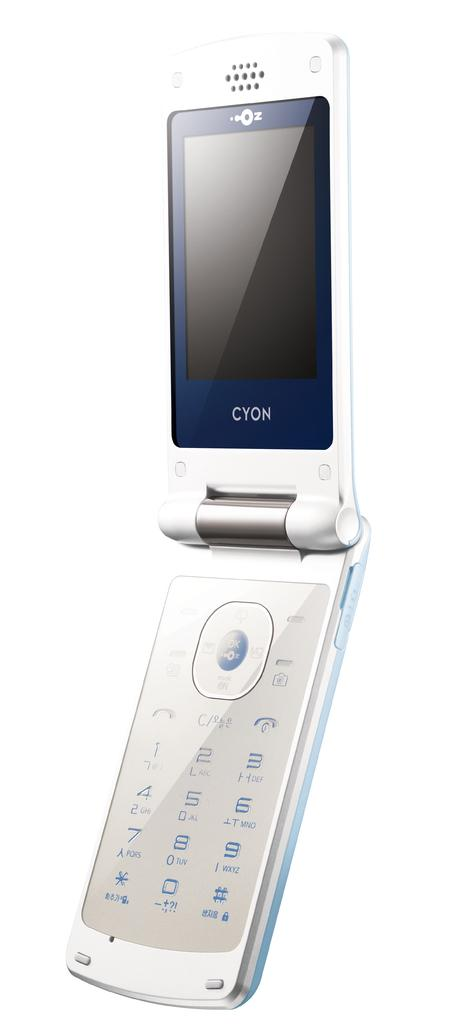<image>
Create a compact narrative representing the image presented. a phone that has the word cyon on it 